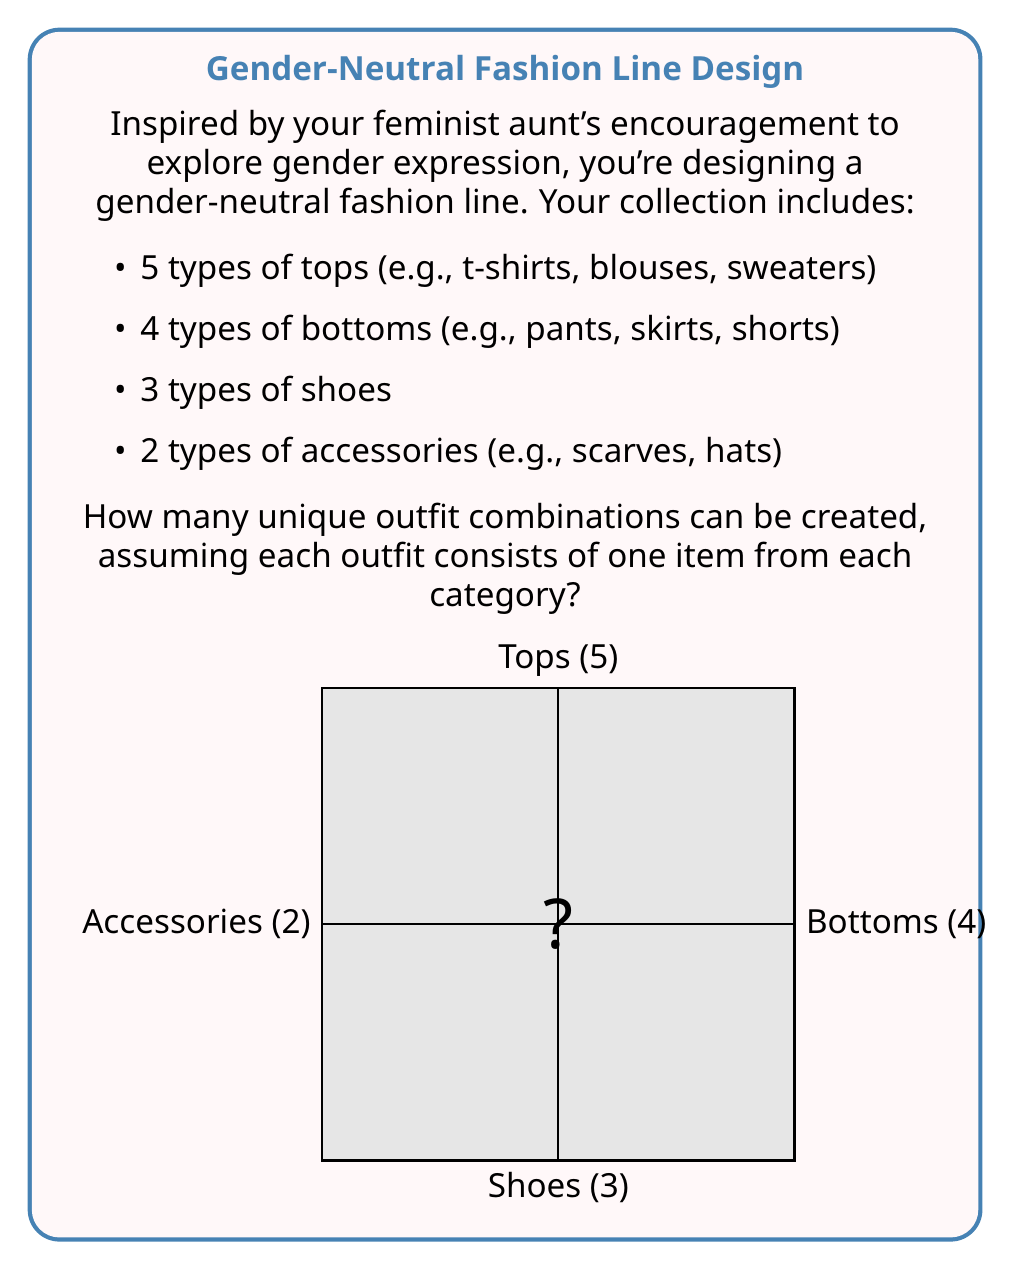Show me your answer to this math problem. Let's approach this step-by-step using the multiplication principle of counting:

1) For each outfit, we need to choose:
   - 1 top out of 5 options
   - 1 bottom out of 4 options
   - 1 pair of shoes out of 3 options
   - 1 accessory out of 2 options

2) The multiplication principle states that if we have a series of independent choices, the total number of ways to make these choices is the product of the number of ways to make each individual choice.

3) Therefore, the total number of possible outfit combinations is:

   $$ \text{Total combinations} = 5 \times 4 \times 3 \times 2 $$

4) Let's calculate:
   $$ 5 \times 4 \times 3 \times 2 = 120 $$

This means there are 120 unique ways to combine one item from each category to create a gender-neutral outfit.
Answer: 120 outfit combinations 